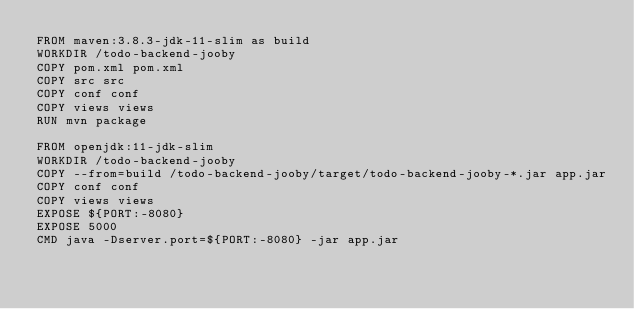<code> <loc_0><loc_0><loc_500><loc_500><_Dockerfile_>FROM maven:3.8.3-jdk-11-slim as build
WORKDIR /todo-backend-jooby
COPY pom.xml pom.xml
COPY src src
COPY conf conf
COPY views views
RUN mvn package

FROM openjdk:11-jdk-slim
WORKDIR /todo-backend-jooby
COPY --from=build /todo-backend-jooby/target/todo-backend-jooby-*.jar app.jar
COPY conf conf
COPY views views
EXPOSE ${PORT:-8080}
EXPOSE 5000
CMD java -Dserver.port=${PORT:-8080} -jar app.jar
</code> 